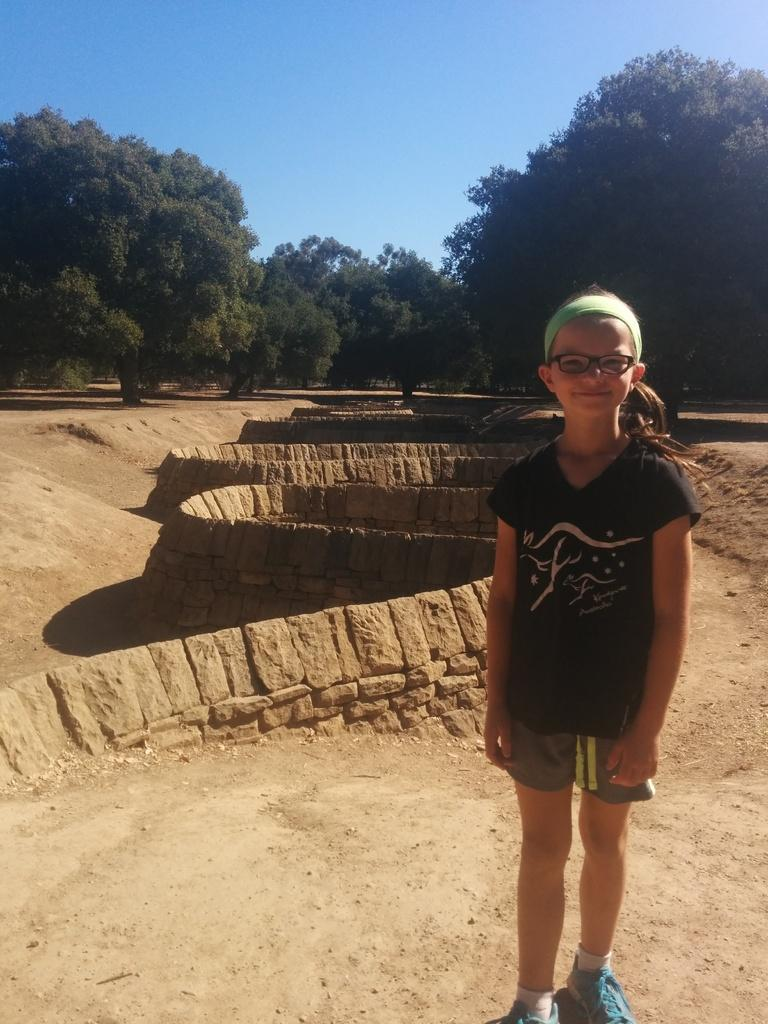Who is the main subject in the image? There is a girl standing in the image. What is the girl doing in the image? The girl is smiling. What can be seen behind the girl in the image? There is a wall in the image. What is visible in the background of the image? There are trees and the sky in the background of the image. What is the color of the sky in the image? The sky is blue in color. How many mist-covered snakes are slithering in the middle of the image? There are no mist-covered snakes present in the image. 